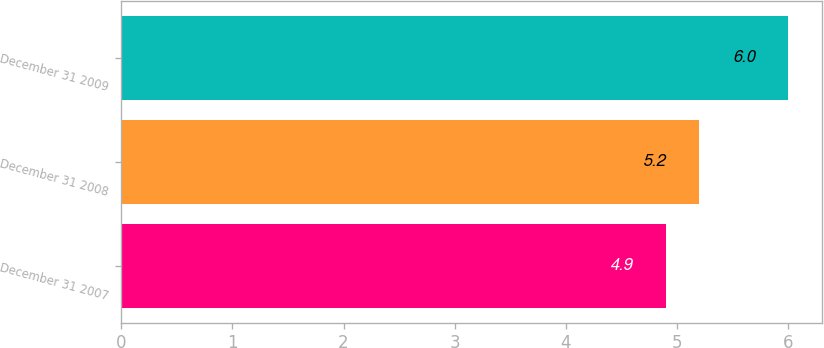Convert chart to OTSL. <chart><loc_0><loc_0><loc_500><loc_500><bar_chart><fcel>December 31 2007<fcel>December 31 2008<fcel>December 31 2009<nl><fcel>4.9<fcel>5.2<fcel>6<nl></chart> 